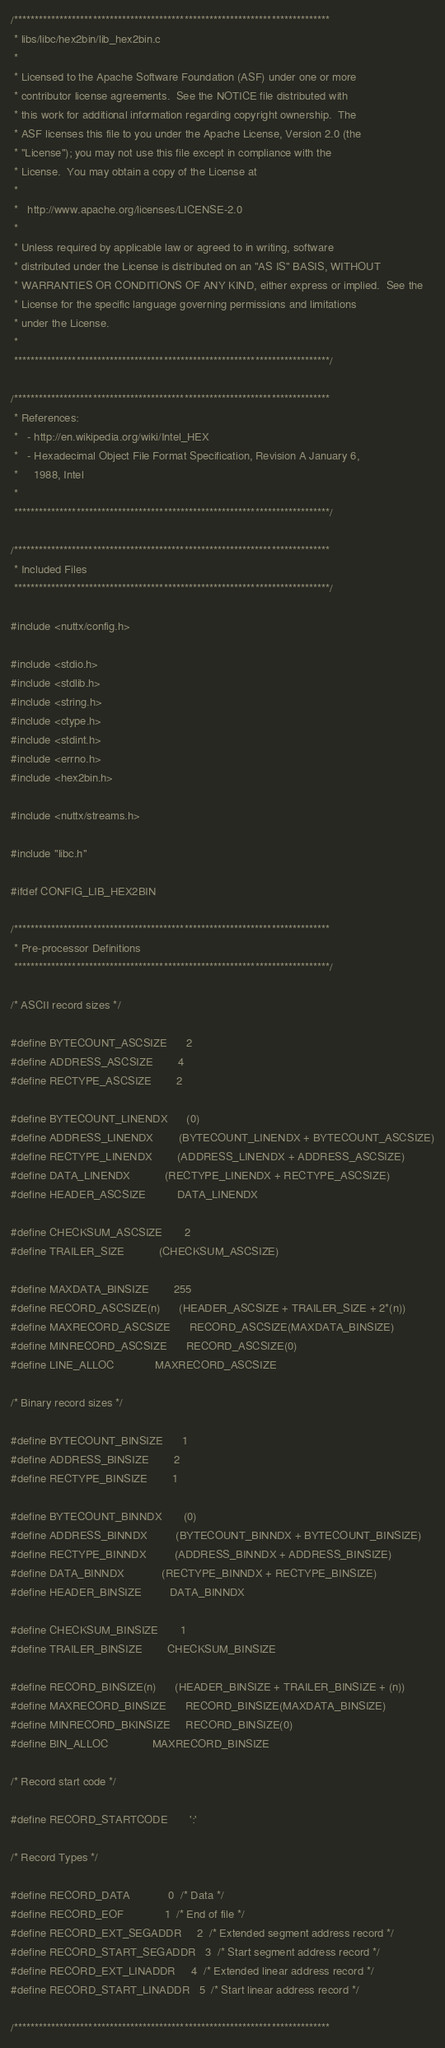Convert code to text. <code><loc_0><loc_0><loc_500><loc_500><_C_>/****************************************************************************
 * libs/libc/hex2bin/lib_hex2bin.c
 *
 * Licensed to the Apache Software Foundation (ASF) under one or more
 * contributor license agreements.  See the NOTICE file distributed with
 * this work for additional information regarding copyright ownership.  The
 * ASF licenses this file to you under the Apache License, Version 2.0 (the
 * "License"); you may not use this file except in compliance with the
 * License.  You may obtain a copy of the License at
 *
 *   http://www.apache.org/licenses/LICENSE-2.0
 *
 * Unless required by applicable law or agreed to in writing, software
 * distributed under the License is distributed on an "AS IS" BASIS, WITHOUT
 * WARRANTIES OR CONDITIONS OF ANY KIND, either express or implied.  See the
 * License for the specific language governing permissions and limitations
 * under the License.
 *
 ****************************************************************************/

/****************************************************************************
 * References:
 *   - http://en.wikipedia.org/wiki/Intel_HEX
 *   - Hexadecimal Object File Format Specification, Revision A January 6,
 *     1988, Intel
 *
 ****************************************************************************/

/****************************************************************************
 * Included Files
 ****************************************************************************/

#include <nuttx/config.h>

#include <stdio.h>
#include <stdlib.h>
#include <string.h>
#include <ctype.h>
#include <stdint.h>
#include <errno.h>
#include <hex2bin.h>

#include <nuttx/streams.h>

#include "libc.h"

#ifdef CONFIG_LIB_HEX2BIN

/****************************************************************************
 * Pre-processor Definitions
 ****************************************************************************/

/* ASCII record sizes */

#define BYTECOUNT_ASCSIZE      2
#define ADDRESS_ASCSIZE        4
#define RECTYPE_ASCSIZE        2

#define BYTECOUNT_LINENDX      (0)
#define ADDRESS_LINENDX        (BYTECOUNT_LINENDX + BYTECOUNT_ASCSIZE)
#define RECTYPE_LINENDX        (ADDRESS_LINENDX + ADDRESS_ASCSIZE)
#define DATA_LINENDX           (RECTYPE_LINENDX + RECTYPE_ASCSIZE)
#define HEADER_ASCSIZE          DATA_LINENDX

#define CHECKSUM_ASCSIZE       2
#define TRAILER_SIZE           (CHECKSUM_ASCSIZE)

#define MAXDATA_BINSIZE        255
#define RECORD_ASCSIZE(n)      (HEADER_ASCSIZE + TRAILER_SIZE + 2*(n))
#define MAXRECORD_ASCSIZE      RECORD_ASCSIZE(MAXDATA_BINSIZE)
#define MINRECORD_ASCSIZE      RECORD_ASCSIZE(0)
#define LINE_ALLOC             MAXRECORD_ASCSIZE

/* Binary record sizes */

#define BYTECOUNT_BINSIZE      1
#define ADDRESS_BINSIZE        2
#define RECTYPE_BINSIZE        1

#define BYTECOUNT_BINNDX       (0)
#define ADDRESS_BINNDX         (BYTECOUNT_BINNDX + BYTECOUNT_BINSIZE)
#define RECTYPE_BINNDX         (ADDRESS_BINNDX + ADDRESS_BINSIZE)
#define DATA_BINNDX            (RECTYPE_BINNDX + RECTYPE_BINSIZE)
#define HEADER_BINSIZE         DATA_BINNDX

#define CHECKSUM_BINSIZE       1
#define TRAILER_BINSIZE        CHECKSUM_BINSIZE

#define RECORD_BINSIZE(n)      (HEADER_BINSIZE + TRAILER_BINSIZE + (n))
#define MAXRECORD_BINSIZE      RECORD_BINSIZE(MAXDATA_BINSIZE)
#define MINRECORD_BKINSIZE     RECORD_BINSIZE(0)
#define BIN_ALLOC              MAXRECORD_BINSIZE

/* Record start code */

#define RECORD_STARTCODE       ':'

/* Record Types */

#define RECORD_DATA            0  /* Data */
#define RECORD_EOF             1  /* End of file */
#define RECORD_EXT_SEGADDR     2  /* Extended segment address record */
#define RECORD_START_SEGADDR   3  /* Start segment address record */
#define RECORD_EXT_LINADDR     4  /* Extended linear address record */
#define RECORD_START_LINADDR   5  /* Start linear address record */

/****************************************************************************</code> 